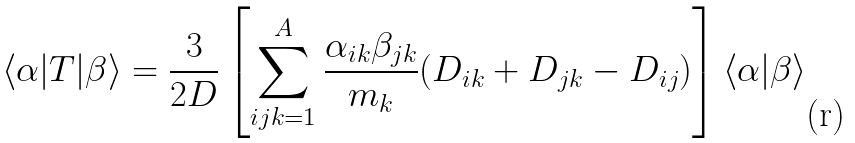<formula> <loc_0><loc_0><loc_500><loc_500>\langle \alpha | T | \beta \rangle = \frac { 3 } { 2 D } \left [ \sum _ { i j k = 1 } ^ { A } \frac { \alpha _ { i k } \beta _ { j k } } { m _ { k } } ( D _ { i k } + D _ { j k } - D _ { i j } ) \right ] \langle \alpha | \beta \rangle</formula> 